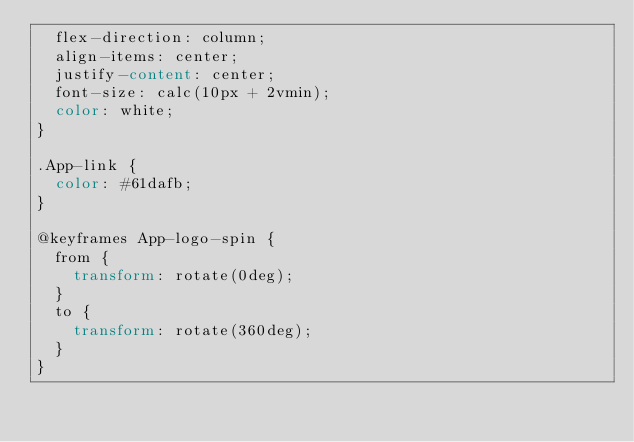Convert code to text. <code><loc_0><loc_0><loc_500><loc_500><_CSS_>  flex-direction: column;
  align-items: center;
  justify-content: center;
  font-size: calc(10px + 2vmin);
  color: white;
}

.App-link {
  color: #61dafb;
}

@keyframes App-logo-spin {
  from {
    transform: rotate(0deg);
  }
  to {
    transform: rotate(360deg);
  }
}
</code> 